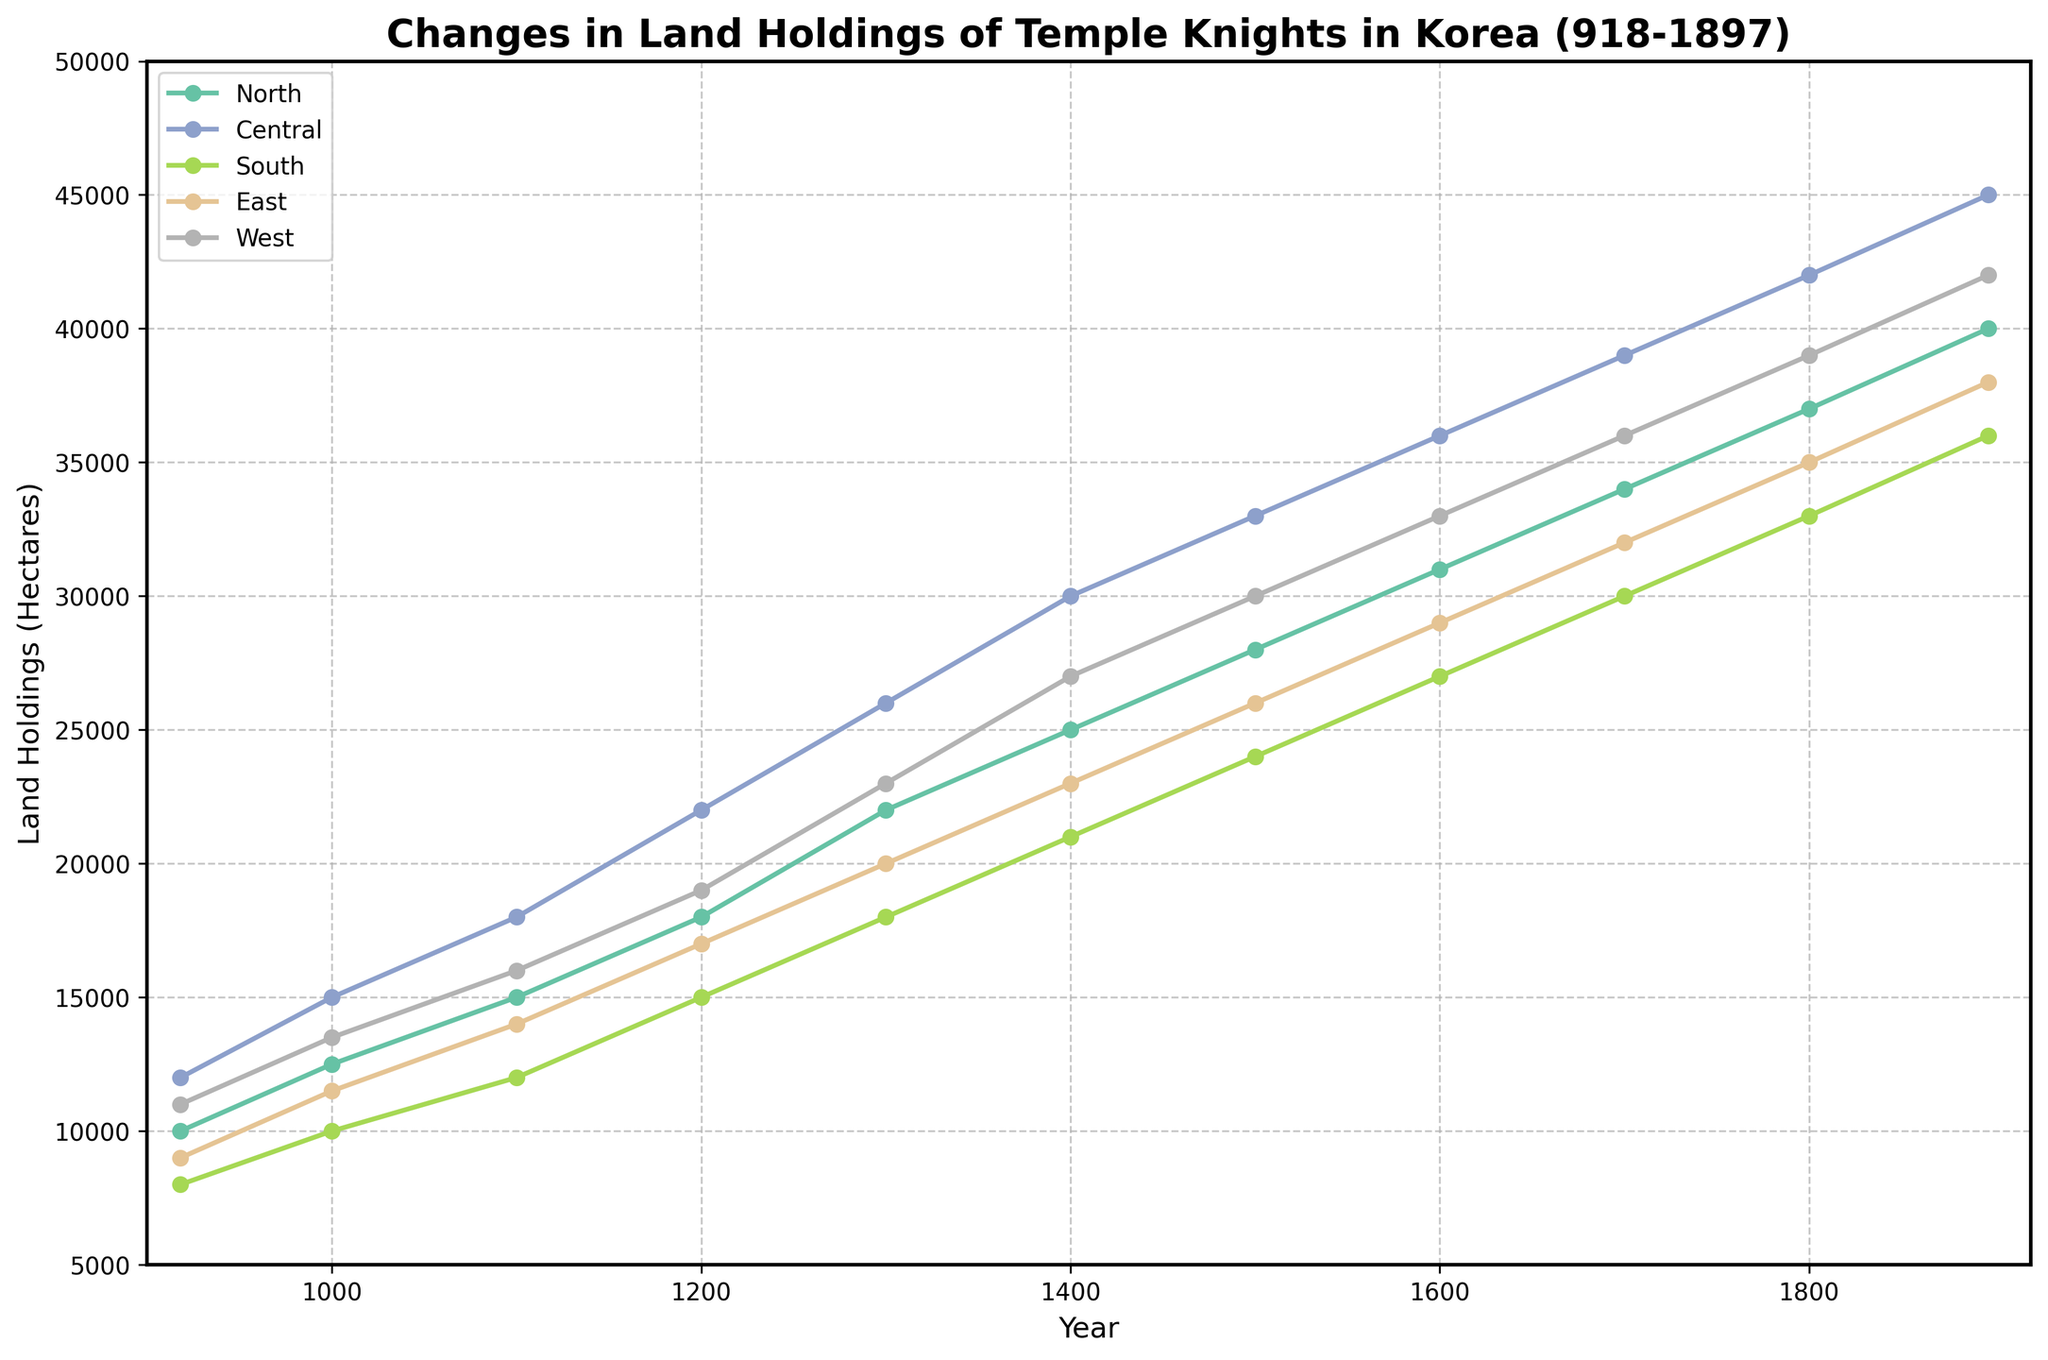what is the percentage increase in land holdings in the North region from 918 to 1897? To find the percentage increase, first calculate the initial and final values: 10,000 hectares in 918 and 40,000 hectares in 1897. The percentage increase is ((40,000 - 10,000) / 10,000) * 100.
Answer: 300% Which region had the highest land holdings in 1500? Look at the data points for the year 1500 across all regions. The data shows Central has the highest value at 33,000 hectares.
Answer: Central What is the combined land holdings for the East and West regions in 1300? Find the data points for East (20,000 hectares) and West (23,000 hectares) in 1300, then sum them: 20,000 + 23,000 = 43,000 hectares.
Answer: 43,000 How does the change in land holdings in the South region from 1100 to 1400 compare to the change in the North region in the same period? Calculate the changes: South from 12,000 to 21,000 hectares (increase by 9,000) and North from 15,000 to 25,000 hectares (increase by 10,000). Compare the magnitude of the changes: 9,000 vs. 10,000. The North increased more.
Answer: North increased more Which region had the steepest increase in land holdings between 1200 and 1800? Measure the increase for each region: North from 18,000 to 37,000 (+19,000), Central from 22,000 to 42,000 (+20,000), South from 15,000 to 33,000 (+18,000), East from 17,000 to 35,000 (+18,000), West from 19,000 to 39,000 (+20,000). Central and West both had the steepest rise.
Answer: Central and West How much land holdings did the Central region gain between 1600 and 1700? Find the Central region values in 1600 (36,000) and 1700 (39,000), and then calculate the difference: 39,000 - 36,000 = 3,000 hectares.
Answer: 3,000 Which two regions show the closest values in land holdings in 1897? Compare the data points for 1897. East (38,000) and South (36,000) are the closest, with a difference of 2,000 hectares.
Answer: East and South What is the average land holdings for the East region over the entire period? Calculate the sum of East land holdings and divide by the number of years: (9,000 + 11,500 + 14,000 + 17,000 + 20,000 + 23,000 + 26,000 + 29,000 + 32,000 + 35,000 + 38,000) / 11 = 25,636.36 hectares.
Answer: 25,636.36 What is the total land holdings across all regions in 1200? Sum the values for 1200: North (18,000) + Central (22,000) + South (15,000) + East (17,000) + West (19,000) = 91,000 hectares.
Answer: 91,000 Which region had the slowest overall increase in land holdings from 918 to 1897? Compare the increases for each region by subtracting 918 values from 1897 values: North (30,000), Central (33,000), South (28,000), East (29,000), West (31,000). South had the slowest increase.
Answer: South 